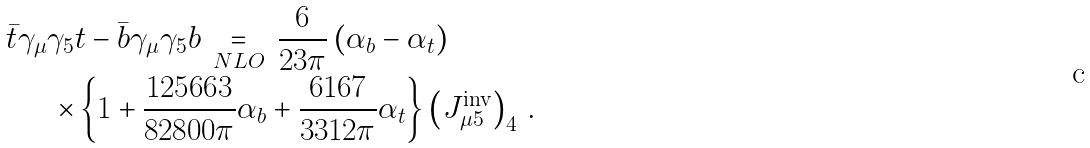<formula> <loc_0><loc_0><loc_500><loc_500>\bar { t } \gamma _ { \mu } \gamma _ { 5 } & t - \bar { b } \gamma _ { \mu } \gamma _ { 5 } b \, \underset { N L O } { = } \, \frac { 6 } { 2 3 \pi } \left ( \alpha _ { b } - \alpha _ { t } \right ) \\ \times & \left \{ 1 + \frac { 1 2 5 6 6 3 } { 8 2 8 0 0 \pi } \alpha _ { b } + \frac { 6 1 6 7 } { 3 3 1 2 \pi } \alpha _ { t } \right \} \left ( J _ { \mu 5 } ^ { \text {inv} } \right ) _ { 4 } \, .</formula> 